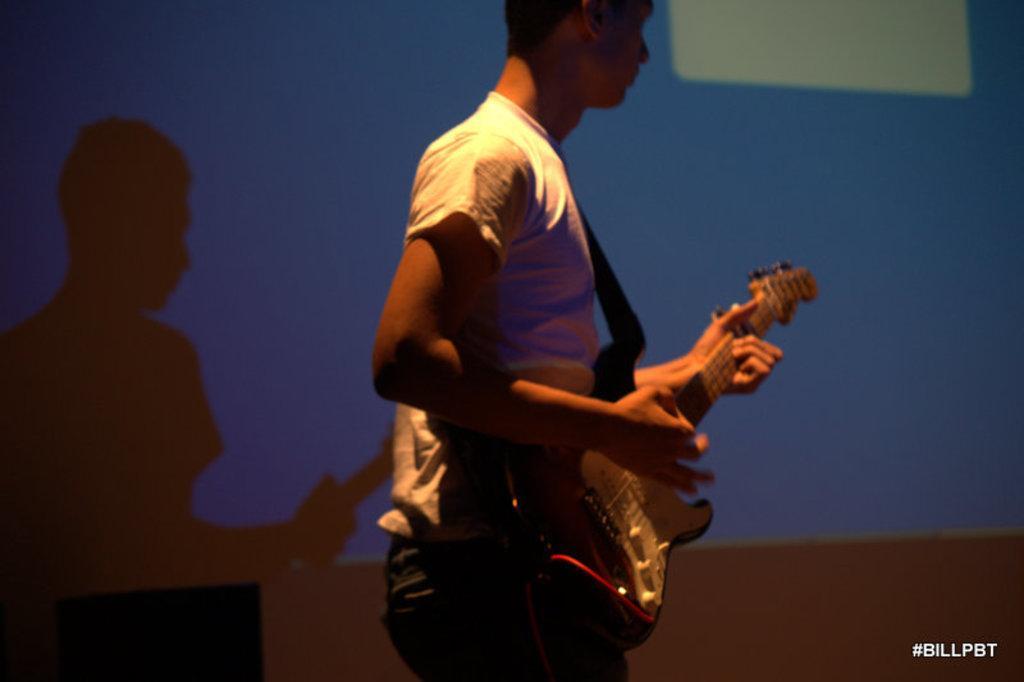Can you describe this image briefly? One person is present in the picture where he is playing a guitar and wearing a white t-shirt and jeans and behind him there is one screen. 